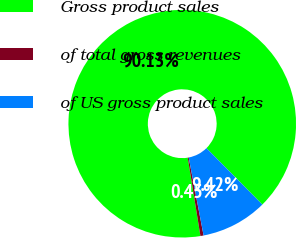<chart> <loc_0><loc_0><loc_500><loc_500><pie_chart><fcel>Gross product sales<fcel>of total gross revenues<fcel>of US gross product sales<nl><fcel>90.14%<fcel>0.45%<fcel>9.42%<nl></chart> 